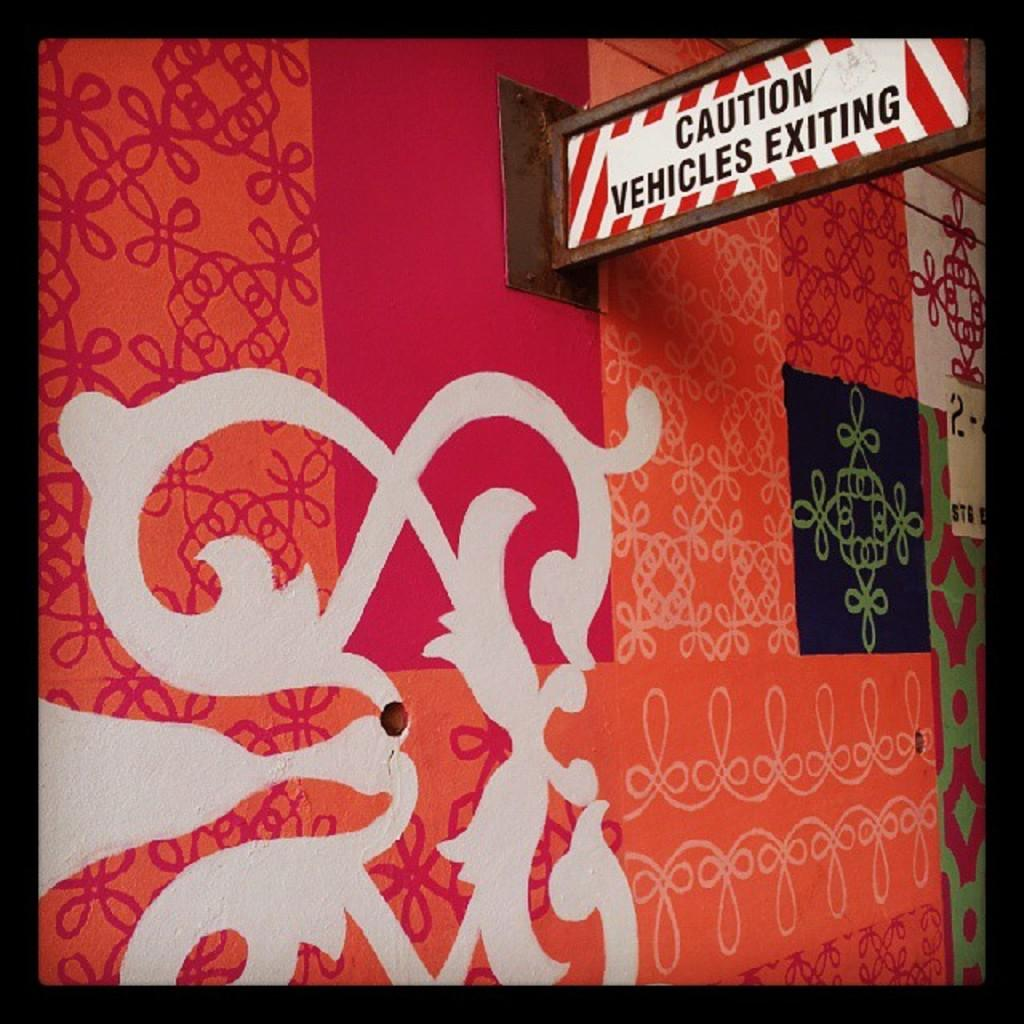<image>
Provide a brief description of the given image. A sign indicates "caution vehicles exiting" on the side of a building. 